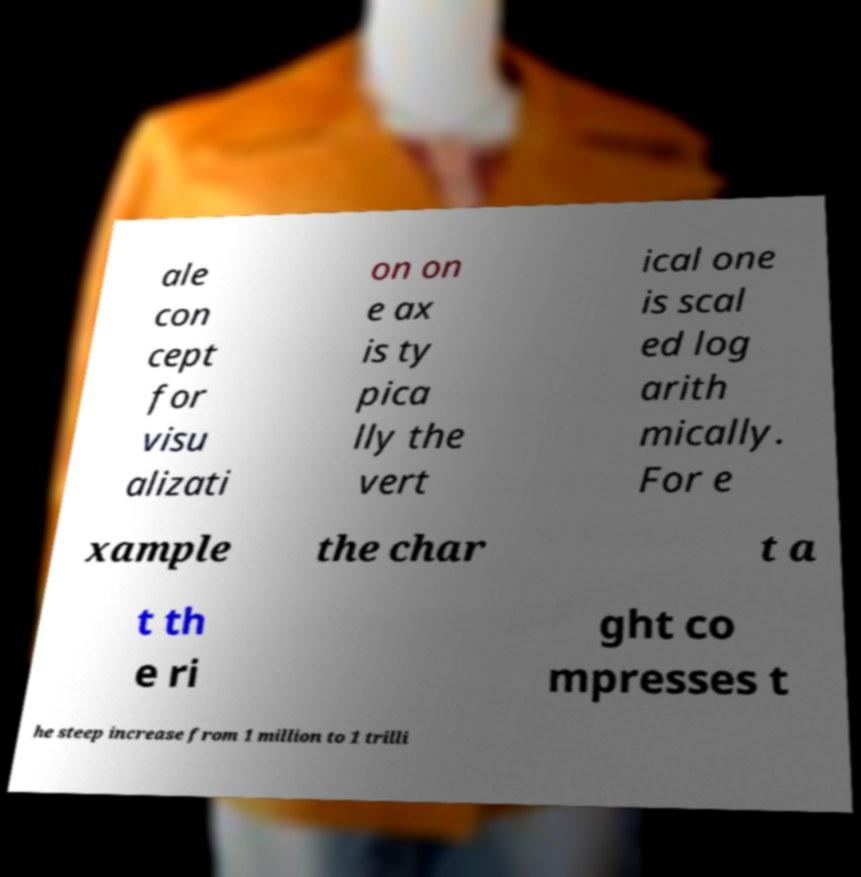What messages or text are displayed in this image? I need them in a readable, typed format. ale con cept for visu alizati on on e ax is ty pica lly the vert ical one is scal ed log arith mically. For e xample the char t a t th e ri ght co mpresses t he steep increase from 1 million to 1 trilli 